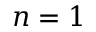<formula> <loc_0><loc_0><loc_500><loc_500>n = 1</formula> 